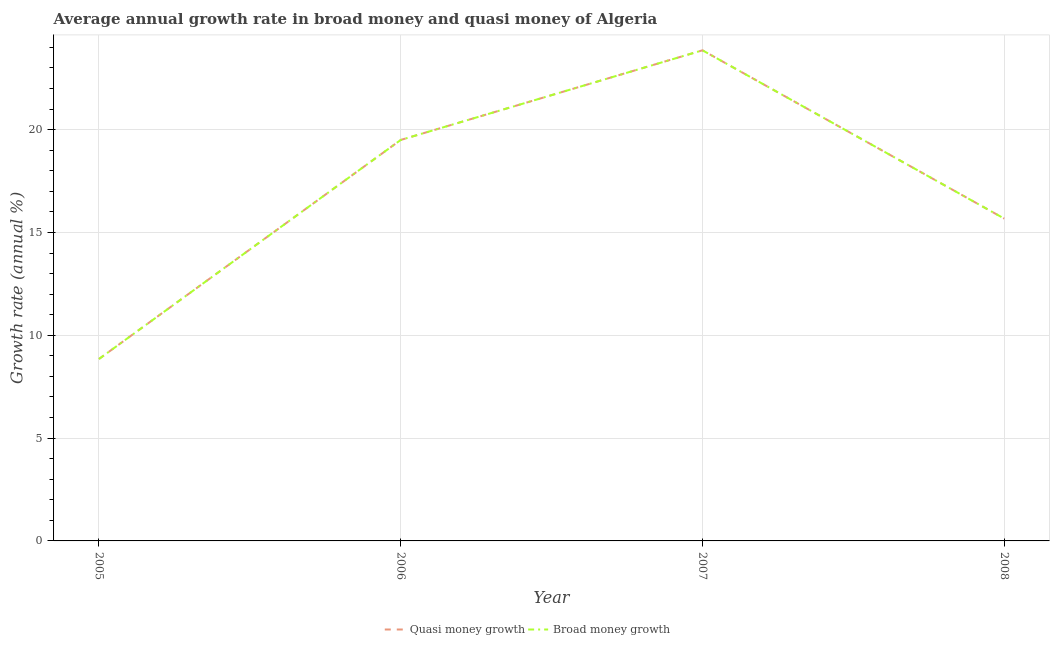How many different coloured lines are there?
Make the answer very short. 2. Does the line corresponding to annual growth rate in broad money intersect with the line corresponding to annual growth rate in quasi money?
Your answer should be very brief. Yes. Is the number of lines equal to the number of legend labels?
Offer a very short reply. Yes. What is the annual growth rate in quasi money in 2008?
Give a very brief answer. 15.67. Across all years, what is the maximum annual growth rate in broad money?
Offer a very short reply. 23.86. Across all years, what is the minimum annual growth rate in quasi money?
Your answer should be compact. 8.85. What is the total annual growth rate in broad money in the graph?
Provide a succinct answer. 67.88. What is the difference between the annual growth rate in quasi money in 2006 and that in 2008?
Your response must be concise. 3.82. What is the difference between the annual growth rate in broad money in 2008 and the annual growth rate in quasi money in 2005?
Provide a succinct answer. 6.83. What is the average annual growth rate in broad money per year?
Ensure brevity in your answer.  16.97. In how many years, is the annual growth rate in broad money greater than 14 %?
Your answer should be very brief. 3. What is the ratio of the annual growth rate in broad money in 2005 to that in 2006?
Keep it short and to the point. 0.45. Is the difference between the annual growth rate in quasi money in 2007 and 2008 greater than the difference between the annual growth rate in broad money in 2007 and 2008?
Keep it short and to the point. No. What is the difference between the highest and the second highest annual growth rate in quasi money?
Make the answer very short. 4.36. What is the difference between the highest and the lowest annual growth rate in broad money?
Give a very brief answer. 15.01. Does the annual growth rate in quasi money monotonically increase over the years?
Offer a very short reply. No. Is the annual growth rate in broad money strictly greater than the annual growth rate in quasi money over the years?
Make the answer very short. No. Is the annual growth rate in broad money strictly less than the annual growth rate in quasi money over the years?
Ensure brevity in your answer.  No. How many lines are there?
Ensure brevity in your answer.  2. How many years are there in the graph?
Provide a succinct answer. 4. What is the difference between two consecutive major ticks on the Y-axis?
Offer a very short reply. 5. Are the values on the major ticks of Y-axis written in scientific E-notation?
Ensure brevity in your answer.  No. Does the graph contain grids?
Ensure brevity in your answer.  Yes. What is the title of the graph?
Provide a succinct answer. Average annual growth rate in broad money and quasi money of Algeria. What is the label or title of the Y-axis?
Your response must be concise. Growth rate (annual %). What is the Growth rate (annual %) of Quasi money growth in 2005?
Ensure brevity in your answer.  8.85. What is the Growth rate (annual %) of Broad money growth in 2005?
Make the answer very short. 8.85. What is the Growth rate (annual %) of Quasi money growth in 2006?
Give a very brief answer. 19.5. What is the Growth rate (annual %) of Broad money growth in 2006?
Give a very brief answer. 19.5. What is the Growth rate (annual %) in Quasi money growth in 2007?
Give a very brief answer. 23.86. What is the Growth rate (annual %) in Broad money growth in 2007?
Provide a short and direct response. 23.86. What is the Growth rate (annual %) of Quasi money growth in 2008?
Your answer should be compact. 15.67. What is the Growth rate (annual %) in Broad money growth in 2008?
Your answer should be compact. 15.67. Across all years, what is the maximum Growth rate (annual %) of Quasi money growth?
Provide a short and direct response. 23.86. Across all years, what is the maximum Growth rate (annual %) in Broad money growth?
Your answer should be compact. 23.86. Across all years, what is the minimum Growth rate (annual %) of Quasi money growth?
Ensure brevity in your answer.  8.85. Across all years, what is the minimum Growth rate (annual %) in Broad money growth?
Provide a succinct answer. 8.85. What is the total Growth rate (annual %) of Quasi money growth in the graph?
Ensure brevity in your answer.  67.88. What is the total Growth rate (annual %) in Broad money growth in the graph?
Give a very brief answer. 67.88. What is the difference between the Growth rate (annual %) of Quasi money growth in 2005 and that in 2006?
Give a very brief answer. -10.65. What is the difference between the Growth rate (annual %) of Broad money growth in 2005 and that in 2006?
Provide a succinct answer. -10.65. What is the difference between the Growth rate (annual %) in Quasi money growth in 2005 and that in 2007?
Give a very brief answer. -15.01. What is the difference between the Growth rate (annual %) in Broad money growth in 2005 and that in 2007?
Provide a succinct answer. -15.01. What is the difference between the Growth rate (annual %) in Quasi money growth in 2005 and that in 2008?
Ensure brevity in your answer.  -6.83. What is the difference between the Growth rate (annual %) of Broad money growth in 2005 and that in 2008?
Offer a very short reply. -6.83. What is the difference between the Growth rate (annual %) of Quasi money growth in 2006 and that in 2007?
Your response must be concise. -4.36. What is the difference between the Growth rate (annual %) of Broad money growth in 2006 and that in 2007?
Your response must be concise. -4.36. What is the difference between the Growth rate (annual %) of Quasi money growth in 2006 and that in 2008?
Your answer should be very brief. 3.82. What is the difference between the Growth rate (annual %) in Broad money growth in 2006 and that in 2008?
Ensure brevity in your answer.  3.82. What is the difference between the Growth rate (annual %) in Quasi money growth in 2007 and that in 2008?
Give a very brief answer. 8.18. What is the difference between the Growth rate (annual %) in Broad money growth in 2007 and that in 2008?
Your response must be concise. 8.18. What is the difference between the Growth rate (annual %) of Quasi money growth in 2005 and the Growth rate (annual %) of Broad money growth in 2006?
Keep it short and to the point. -10.65. What is the difference between the Growth rate (annual %) in Quasi money growth in 2005 and the Growth rate (annual %) in Broad money growth in 2007?
Ensure brevity in your answer.  -15.01. What is the difference between the Growth rate (annual %) in Quasi money growth in 2005 and the Growth rate (annual %) in Broad money growth in 2008?
Your answer should be compact. -6.83. What is the difference between the Growth rate (annual %) of Quasi money growth in 2006 and the Growth rate (annual %) of Broad money growth in 2007?
Your response must be concise. -4.36. What is the difference between the Growth rate (annual %) in Quasi money growth in 2006 and the Growth rate (annual %) in Broad money growth in 2008?
Ensure brevity in your answer.  3.82. What is the difference between the Growth rate (annual %) of Quasi money growth in 2007 and the Growth rate (annual %) of Broad money growth in 2008?
Your answer should be compact. 8.18. What is the average Growth rate (annual %) of Quasi money growth per year?
Your answer should be very brief. 16.97. What is the average Growth rate (annual %) in Broad money growth per year?
Offer a very short reply. 16.97. In the year 2007, what is the difference between the Growth rate (annual %) of Quasi money growth and Growth rate (annual %) of Broad money growth?
Offer a terse response. 0. What is the ratio of the Growth rate (annual %) in Quasi money growth in 2005 to that in 2006?
Ensure brevity in your answer.  0.45. What is the ratio of the Growth rate (annual %) in Broad money growth in 2005 to that in 2006?
Offer a very short reply. 0.45. What is the ratio of the Growth rate (annual %) in Quasi money growth in 2005 to that in 2007?
Keep it short and to the point. 0.37. What is the ratio of the Growth rate (annual %) in Broad money growth in 2005 to that in 2007?
Keep it short and to the point. 0.37. What is the ratio of the Growth rate (annual %) in Quasi money growth in 2005 to that in 2008?
Make the answer very short. 0.56. What is the ratio of the Growth rate (annual %) in Broad money growth in 2005 to that in 2008?
Give a very brief answer. 0.56. What is the ratio of the Growth rate (annual %) in Quasi money growth in 2006 to that in 2007?
Ensure brevity in your answer.  0.82. What is the ratio of the Growth rate (annual %) of Broad money growth in 2006 to that in 2007?
Offer a terse response. 0.82. What is the ratio of the Growth rate (annual %) in Quasi money growth in 2006 to that in 2008?
Make the answer very short. 1.24. What is the ratio of the Growth rate (annual %) of Broad money growth in 2006 to that in 2008?
Your answer should be compact. 1.24. What is the ratio of the Growth rate (annual %) in Quasi money growth in 2007 to that in 2008?
Ensure brevity in your answer.  1.52. What is the ratio of the Growth rate (annual %) of Broad money growth in 2007 to that in 2008?
Offer a terse response. 1.52. What is the difference between the highest and the second highest Growth rate (annual %) in Quasi money growth?
Your answer should be compact. 4.36. What is the difference between the highest and the second highest Growth rate (annual %) in Broad money growth?
Offer a terse response. 4.36. What is the difference between the highest and the lowest Growth rate (annual %) of Quasi money growth?
Ensure brevity in your answer.  15.01. What is the difference between the highest and the lowest Growth rate (annual %) in Broad money growth?
Give a very brief answer. 15.01. 